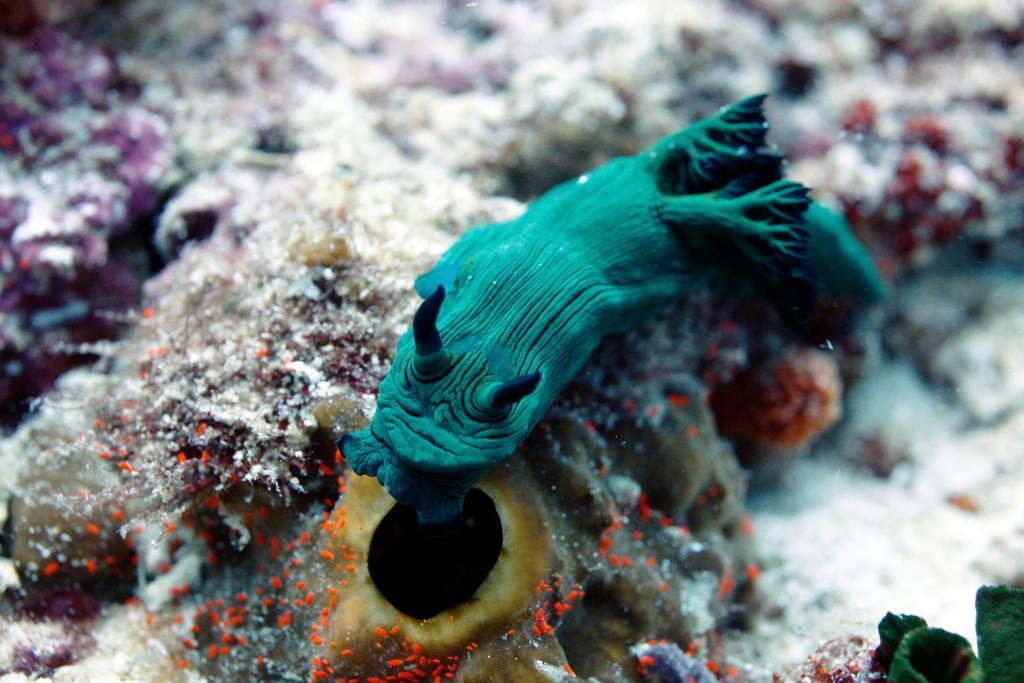Could you give a brief overview of what you see in this image? The image is taken in the aquarium. In the center of the image we can see a fish. At the bottom there are water plants. 